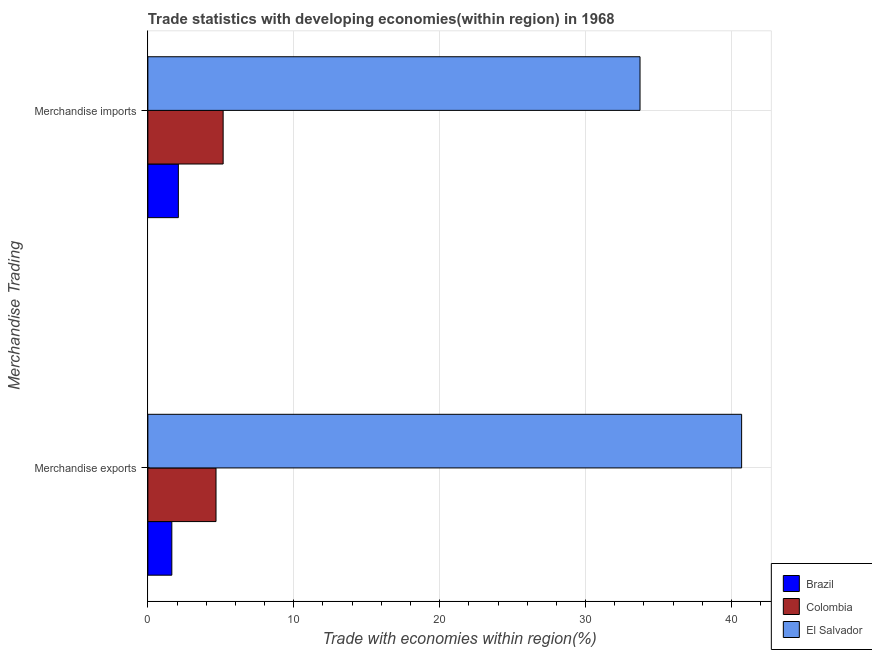How many groups of bars are there?
Keep it short and to the point. 2. Are the number of bars per tick equal to the number of legend labels?
Your answer should be very brief. Yes. How many bars are there on the 2nd tick from the top?
Your response must be concise. 3. How many bars are there on the 1st tick from the bottom?
Make the answer very short. 3. What is the label of the 2nd group of bars from the top?
Your response must be concise. Merchandise exports. What is the merchandise imports in El Salvador?
Provide a short and direct response. 33.73. Across all countries, what is the maximum merchandise exports?
Offer a terse response. 40.69. Across all countries, what is the minimum merchandise exports?
Keep it short and to the point. 1.64. In which country was the merchandise exports maximum?
Keep it short and to the point. El Salvador. In which country was the merchandise exports minimum?
Provide a succinct answer. Brazil. What is the total merchandise imports in the graph?
Provide a short and direct response. 40.98. What is the difference between the merchandise exports in El Salvador and that in Colombia?
Give a very brief answer. 36.02. What is the difference between the merchandise exports in Brazil and the merchandise imports in El Salvador?
Your answer should be very brief. -32.09. What is the average merchandise exports per country?
Provide a succinct answer. 15.67. What is the difference between the merchandise exports and merchandise imports in Brazil?
Your answer should be very brief. -0.45. What is the ratio of the merchandise exports in Brazil to that in Colombia?
Your response must be concise. 0.35. Is the merchandise exports in Brazil less than that in Colombia?
Your answer should be very brief. Yes. What does the 3rd bar from the top in Merchandise exports represents?
Give a very brief answer. Brazil. Are the values on the major ticks of X-axis written in scientific E-notation?
Give a very brief answer. No. Does the graph contain any zero values?
Make the answer very short. No. Does the graph contain grids?
Your answer should be very brief. Yes. What is the title of the graph?
Your answer should be very brief. Trade statistics with developing economies(within region) in 1968. Does "Croatia" appear as one of the legend labels in the graph?
Ensure brevity in your answer.  No. What is the label or title of the X-axis?
Make the answer very short. Trade with economies within region(%). What is the label or title of the Y-axis?
Offer a very short reply. Merchandise Trading. What is the Trade with economies within region(%) of Brazil in Merchandise exports?
Your answer should be compact. 1.64. What is the Trade with economies within region(%) of Colombia in Merchandise exports?
Make the answer very short. 4.67. What is the Trade with economies within region(%) of El Salvador in Merchandise exports?
Give a very brief answer. 40.69. What is the Trade with economies within region(%) in Brazil in Merchandise imports?
Ensure brevity in your answer.  2.09. What is the Trade with economies within region(%) of Colombia in Merchandise imports?
Your answer should be very brief. 5.16. What is the Trade with economies within region(%) of El Salvador in Merchandise imports?
Your answer should be very brief. 33.73. Across all Merchandise Trading, what is the maximum Trade with economies within region(%) in Brazil?
Your response must be concise. 2.09. Across all Merchandise Trading, what is the maximum Trade with economies within region(%) of Colombia?
Keep it short and to the point. 5.16. Across all Merchandise Trading, what is the maximum Trade with economies within region(%) of El Salvador?
Ensure brevity in your answer.  40.69. Across all Merchandise Trading, what is the minimum Trade with economies within region(%) of Brazil?
Ensure brevity in your answer.  1.64. Across all Merchandise Trading, what is the minimum Trade with economies within region(%) of Colombia?
Provide a succinct answer. 4.67. Across all Merchandise Trading, what is the minimum Trade with economies within region(%) of El Salvador?
Your answer should be compact. 33.73. What is the total Trade with economies within region(%) of Brazil in the graph?
Offer a very short reply. 3.73. What is the total Trade with economies within region(%) of Colombia in the graph?
Offer a very short reply. 9.83. What is the total Trade with economies within region(%) in El Salvador in the graph?
Make the answer very short. 74.42. What is the difference between the Trade with economies within region(%) in Brazil in Merchandise exports and that in Merchandise imports?
Offer a very short reply. -0.45. What is the difference between the Trade with economies within region(%) in Colombia in Merchandise exports and that in Merchandise imports?
Your response must be concise. -0.49. What is the difference between the Trade with economies within region(%) in El Salvador in Merchandise exports and that in Merchandise imports?
Provide a short and direct response. 6.96. What is the difference between the Trade with economies within region(%) in Brazil in Merchandise exports and the Trade with economies within region(%) in Colombia in Merchandise imports?
Ensure brevity in your answer.  -3.52. What is the difference between the Trade with economies within region(%) of Brazil in Merchandise exports and the Trade with economies within region(%) of El Salvador in Merchandise imports?
Ensure brevity in your answer.  -32.09. What is the difference between the Trade with economies within region(%) in Colombia in Merchandise exports and the Trade with economies within region(%) in El Salvador in Merchandise imports?
Keep it short and to the point. -29.06. What is the average Trade with economies within region(%) in Brazil per Merchandise Trading?
Your response must be concise. 1.87. What is the average Trade with economies within region(%) in Colombia per Merchandise Trading?
Make the answer very short. 4.91. What is the average Trade with economies within region(%) of El Salvador per Merchandise Trading?
Offer a very short reply. 37.21. What is the difference between the Trade with economies within region(%) of Brazil and Trade with economies within region(%) of Colombia in Merchandise exports?
Keep it short and to the point. -3.03. What is the difference between the Trade with economies within region(%) of Brazil and Trade with economies within region(%) of El Salvador in Merchandise exports?
Offer a terse response. -39.05. What is the difference between the Trade with economies within region(%) of Colombia and Trade with economies within region(%) of El Salvador in Merchandise exports?
Make the answer very short. -36.02. What is the difference between the Trade with economies within region(%) in Brazil and Trade with economies within region(%) in Colombia in Merchandise imports?
Provide a succinct answer. -3.07. What is the difference between the Trade with economies within region(%) of Brazil and Trade with economies within region(%) of El Salvador in Merchandise imports?
Your response must be concise. -31.64. What is the difference between the Trade with economies within region(%) of Colombia and Trade with economies within region(%) of El Salvador in Merchandise imports?
Offer a terse response. -28.57. What is the ratio of the Trade with economies within region(%) in Brazil in Merchandise exports to that in Merchandise imports?
Your answer should be very brief. 0.79. What is the ratio of the Trade with economies within region(%) of Colombia in Merchandise exports to that in Merchandise imports?
Give a very brief answer. 0.91. What is the ratio of the Trade with economies within region(%) in El Salvador in Merchandise exports to that in Merchandise imports?
Provide a short and direct response. 1.21. What is the difference between the highest and the second highest Trade with economies within region(%) in Brazil?
Offer a terse response. 0.45. What is the difference between the highest and the second highest Trade with economies within region(%) of Colombia?
Provide a succinct answer. 0.49. What is the difference between the highest and the second highest Trade with economies within region(%) in El Salvador?
Your answer should be compact. 6.96. What is the difference between the highest and the lowest Trade with economies within region(%) of Brazil?
Provide a short and direct response. 0.45. What is the difference between the highest and the lowest Trade with economies within region(%) of Colombia?
Your response must be concise. 0.49. What is the difference between the highest and the lowest Trade with economies within region(%) in El Salvador?
Ensure brevity in your answer.  6.96. 